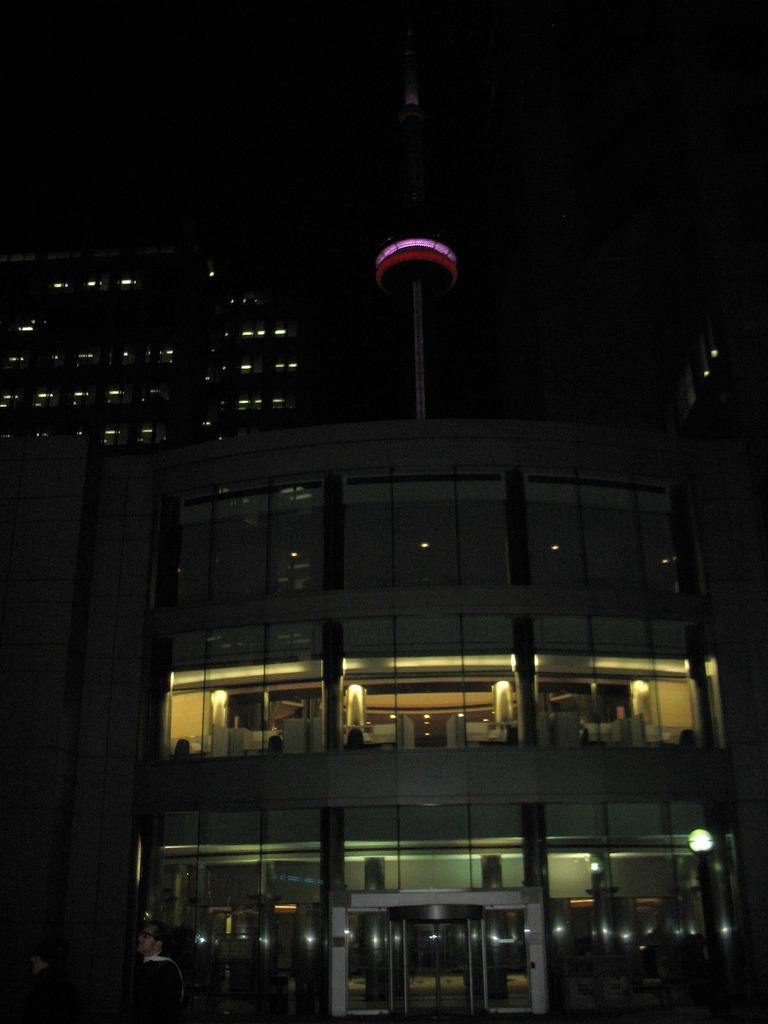What is the setting of the image? The image shows a night view of a building. What features of the building are visible in the image? The building has lights, glass elements, and pillars. Are there any other buildings visible in the image? Yes, other buildings with lights are visible in the image. What type of payment is required to enter the bedroom in the image? There is no bedroom present in the image; it shows a night view of a building with lights and other architectural features. 